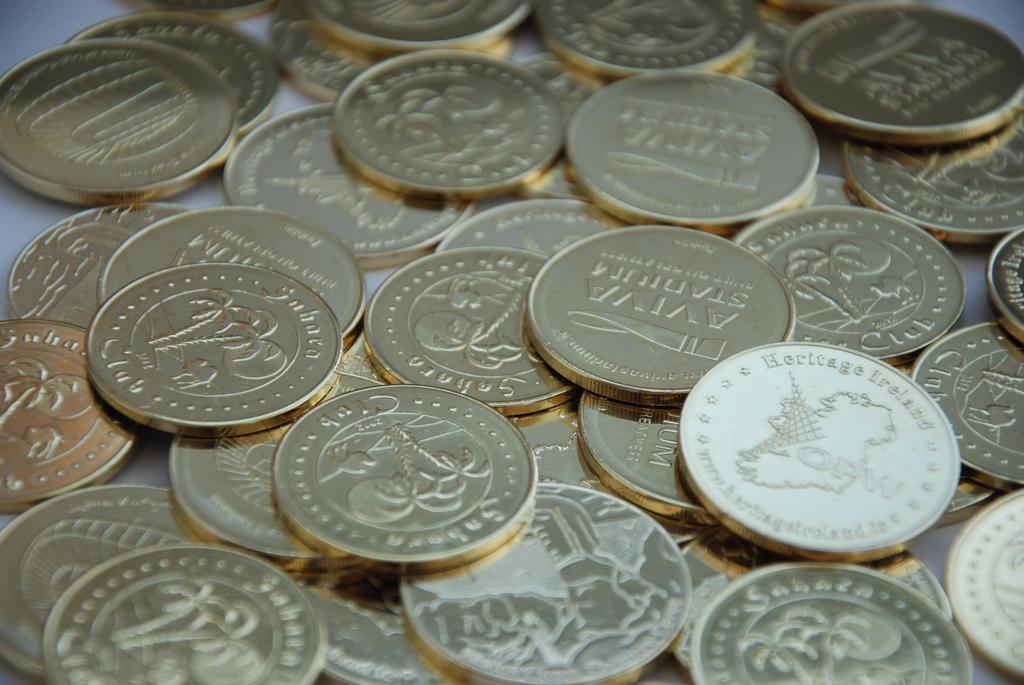<image>
Summarize the visual content of the image. a pile of coins, some with palm trees and some with a man's face, reading sahara 